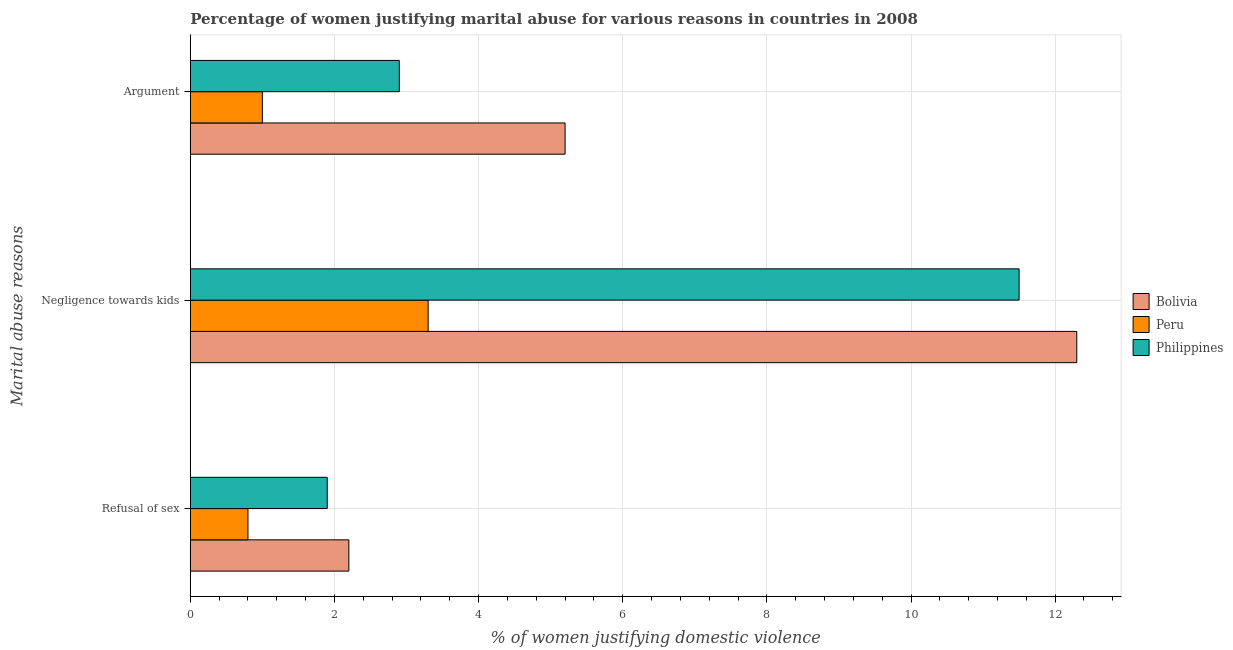How many different coloured bars are there?
Make the answer very short. 3. How many groups of bars are there?
Your answer should be very brief. 3. How many bars are there on the 1st tick from the bottom?
Your answer should be compact. 3. What is the label of the 2nd group of bars from the top?
Your answer should be compact. Negligence towards kids. In which country was the percentage of women justifying domestic violence due to arguments minimum?
Keep it short and to the point. Peru. What is the difference between the percentage of women justifying domestic violence due to refusal of sex in Peru and that in Bolivia?
Your answer should be compact. -1.4. What is the average percentage of women justifying domestic violence due to refusal of sex per country?
Provide a short and direct response. 1.63. In how many countries, is the percentage of women justifying domestic violence due to negligence towards kids greater than 8 %?
Ensure brevity in your answer.  2. What is the ratio of the percentage of women justifying domestic violence due to arguments in Philippines to that in Bolivia?
Make the answer very short. 0.56. Is the percentage of women justifying domestic violence due to negligence towards kids in Philippines less than that in Bolivia?
Offer a very short reply. Yes. Is the difference between the percentage of women justifying domestic violence due to refusal of sex in Peru and Bolivia greater than the difference between the percentage of women justifying domestic violence due to arguments in Peru and Bolivia?
Provide a succinct answer. Yes. What is the difference between the highest and the second highest percentage of women justifying domestic violence due to arguments?
Give a very brief answer. 2.3. What is the difference between the highest and the lowest percentage of women justifying domestic violence due to negligence towards kids?
Make the answer very short. 9. What does the 3rd bar from the bottom in Refusal of sex represents?
Offer a very short reply. Philippines. Are all the bars in the graph horizontal?
Keep it short and to the point. Yes. What is the difference between two consecutive major ticks on the X-axis?
Offer a terse response. 2. Does the graph contain grids?
Ensure brevity in your answer.  Yes. Where does the legend appear in the graph?
Provide a short and direct response. Center right. How many legend labels are there?
Provide a succinct answer. 3. How are the legend labels stacked?
Give a very brief answer. Vertical. What is the title of the graph?
Offer a terse response. Percentage of women justifying marital abuse for various reasons in countries in 2008. Does "Kosovo" appear as one of the legend labels in the graph?
Ensure brevity in your answer.  No. What is the label or title of the X-axis?
Keep it short and to the point. % of women justifying domestic violence. What is the label or title of the Y-axis?
Keep it short and to the point. Marital abuse reasons. What is the % of women justifying domestic violence of Bolivia in Refusal of sex?
Provide a succinct answer. 2.2. What is the % of women justifying domestic violence in Philippines in Refusal of sex?
Make the answer very short. 1.9. What is the % of women justifying domestic violence in Peru in Negligence towards kids?
Your answer should be very brief. 3.3. What is the % of women justifying domestic violence of Bolivia in Argument?
Your answer should be very brief. 5.2. What is the % of women justifying domestic violence of Philippines in Argument?
Your answer should be very brief. 2.9. Across all Marital abuse reasons, what is the maximum % of women justifying domestic violence in Bolivia?
Provide a succinct answer. 12.3. Across all Marital abuse reasons, what is the maximum % of women justifying domestic violence of Philippines?
Your response must be concise. 11.5. Across all Marital abuse reasons, what is the minimum % of women justifying domestic violence in Peru?
Keep it short and to the point. 0.8. Across all Marital abuse reasons, what is the minimum % of women justifying domestic violence in Philippines?
Give a very brief answer. 1.9. What is the total % of women justifying domestic violence of Bolivia in the graph?
Provide a short and direct response. 19.7. What is the total % of women justifying domestic violence of Peru in the graph?
Make the answer very short. 5.1. What is the difference between the % of women justifying domestic violence of Peru in Refusal of sex and that in Negligence towards kids?
Your answer should be compact. -2.5. What is the difference between the % of women justifying domestic violence of Philippines in Refusal of sex and that in Negligence towards kids?
Your answer should be compact. -9.6. What is the difference between the % of women justifying domestic violence in Bolivia in Refusal of sex and that in Argument?
Give a very brief answer. -3. What is the difference between the % of women justifying domestic violence in Philippines in Refusal of sex and that in Argument?
Make the answer very short. -1. What is the difference between the % of women justifying domestic violence in Peru in Negligence towards kids and that in Argument?
Provide a succinct answer. 2.3. What is the difference between the % of women justifying domestic violence in Philippines in Negligence towards kids and that in Argument?
Your answer should be compact. 8.6. What is the difference between the % of women justifying domestic violence of Peru in Refusal of sex and the % of women justifying domestic violence of Philippines in Argument?
Your response must be concise. -2.1. What is the difference between the % of women justifying domestic violence in Bolivia in Negligence towards kids and the % of women justifying domestic violence in Peru in Argument?
Provide a succinct answer. 11.3. What is the average % of women justifying domestic violence in Bolivia per Marital abuse reasons?
Your response must be concise. 6.57. What is the average % of women justifying domestic violence in Peru per Marital abuse reasons?
Provide a short and direct response. 1.7. What is the average % of women justifying domestic violence of Philippines per Marital abuse reasons?
Offer a very short reply. 5.43. What is the difference between the % of women justifying domestic violence in Peru and % of women justifying domestic violence in Philippines in Refusal of sex?
Keep it short and to the point. -1.1. What is the difference between the % of women justifying domestic violence of Bolivia and % of women justifying domestic violence of Philippines in Negligence towards kids?
Offer a very short reply. 0.8. What is the difference between the % of women justifying domestic violence in Bolivia and % of women justifying domestic violence in Peru in Argument?
Your response must be concise. 4.2. What is the ratio of the % of women justifying domestic violence in Bolivia in Refusal of sex to that in Negligence towards kids?
Provide a succinct answer. 0.18. What is the ratio of the % of women justifying domestic violence in Peru in Refusal of sex to that in Negligence towards kids?
Provide a succinct answer. 0.24. What is the ratio of the % of women justifying domestic violence of Philippines in Refusal of sex to that in Negligence towards kids?
Provide a short and direct response. 0.17. What is the ratio of the % of women justifying domestic violence of Bolivia in Refusal of sex to that in Argument?
Your answer should be very brief. 0.42. What is the ratio of the % of women justifying domestic violence of Philippines in Refusal of sex to that in Argument?
Provide a short and direct response. 0.66. What is the ratio of the % of women justifying domestic violence of Bolivia in Negligence towards kids to that in Argument?
Your answer should be very brief. 2.37. What is the ratio of the % of women justifying domestic violence of Peru in Negligence towards kids to that in Argument?
Give a very brief answer. 3.3. What is the ratio of the % of women justifying domestic violence of Philippines in Negligence towards kids to that in Argument?
Provide a succinct answer. 3.97. What is the difference between the highest and the second highest % of women justifying domestic violence in Peru?
Make the answer very short. 2.3. What is the difference between the highest and the second highest % of women justifying domestic violence in Philippines?
Your answer should be compact. 8.6. What is the difference between the highest and the lowest % of women justifying domestic violence of Peru?
Provide a succinct answer. 2.5. What is the difference between the highest and the lowest % of women justifying domestic violence of Philippines?
Ensure brevity in your answer.  9.6. 